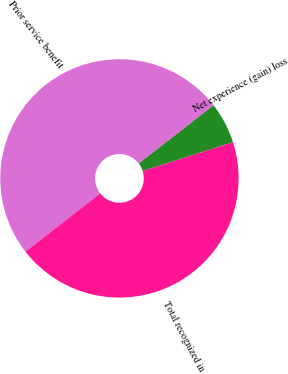Convert chart. <chart><loc_0><loc_0><loc_500><loc_500><pie_chart><fcel>Net experience (gain) loss<fcel>Prior service benefit<fcel>Total recognized in<nl><fcel>5.62%<fcel>50.0%<fcel>44.38%<nl></chart> 